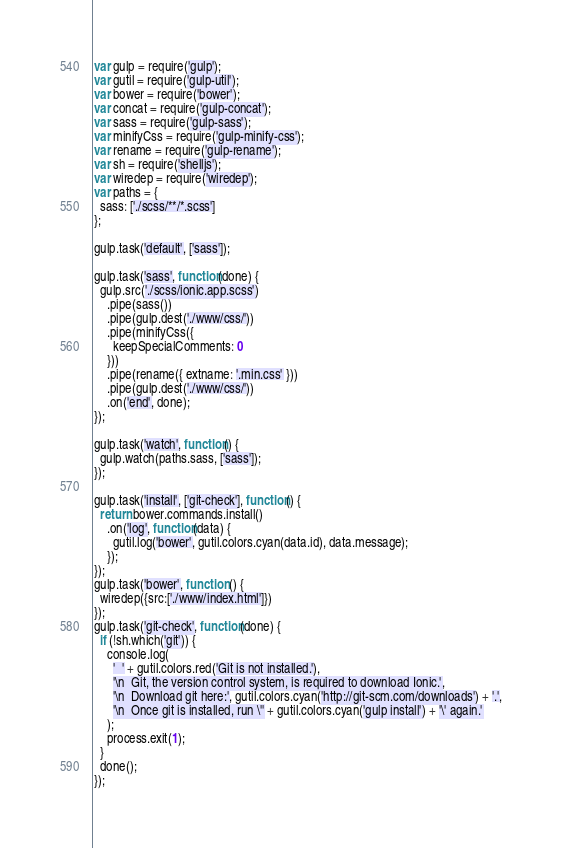<code> <loc_0><loc_0><loc_500><loc_500><_JavaScript_>var gulp = require('gulp');
var gutil = require('gulp-util');
var bower = require('bower');
var concat = require('gulp-concat');
var sass = require('gulp-sass');
var minifyCss = require('gulp-minify-css');
var rename = require('gulp-rename');
var sh = require('shelljs');
var wiredep = require('wiredep');
var paths = {
  sass: ['./scss/**/*.scss']
};

gulp.task('default', ['sass']);

gulp.task('sass', function(done) {
  gulp.src('./scss/ionic.app.scss')
    .pipe(sass())
    .pipe(gulp.dest('./www/css/'))
    .pipe(minifyCss({
      keepSpecialComments: 0
    }))
    .pipe(rename({ extname: '.min.css' }))
    .pipe(gulp.dest('./www/css/'))
    .on('end', done);
});

gulp.task('watch', function() {
  gulp.watch(paths.sass, ['sass']);
});

gulp.task('install', ['git-check'], function() {
  return bower.commands.install()
    .on('log', function(data) {
      gutil.log('bower', gutil.colors.cyan(data.id), data.message);
    });
});
gulp.task('bower', function () {
  wiredep({src:['./www/index.html']})
});
gulp.task('git-check', function(done) {
  if (!sh.which('git')) {
    console.log(
      '  ' + gutil.colors.red('Git is not installed.'),
      '\n  Git, the version control system, is required to download Ionic.',
      '\n  Download git here:', gutil.colors.cyan('http://git-scm.com/downloads') + '.',
      '\n  Once git is installed, run \'' + gutil.colors.cyan('gulp install') + '\' again.'
    );
    process.exit(1);
  }
  done();
});
</code> 